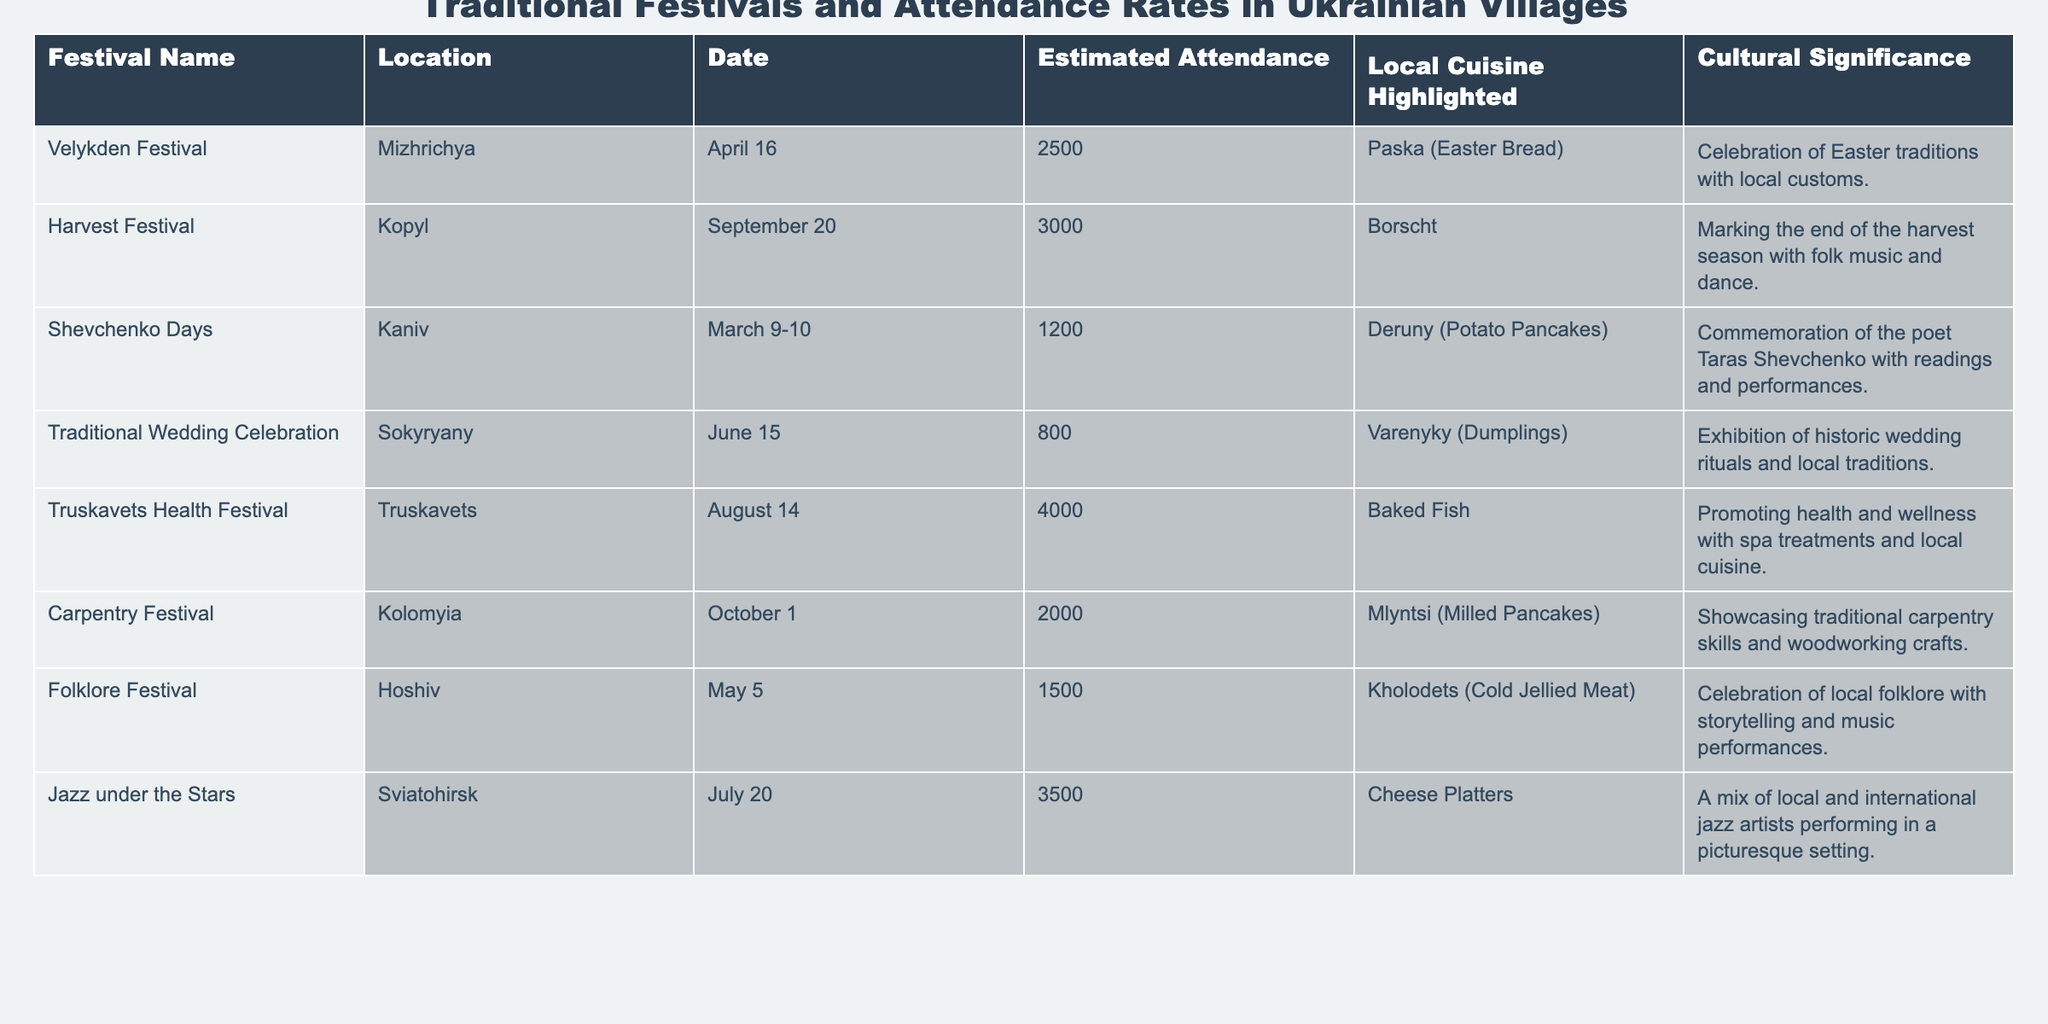What is the estimated attendance at the Harvest Festival? The table lists the Harvest Festival located in Kopyl on September 20, with an estimated attendance of 3000.
Answer: 3000 Which festival has the highest estimated attendance? After reviewing the attendance figures, the Truskavets Health Festival has the highest attendance of 4000.
Answer: 4000 What local cuisine is highlighted at the Shevchenko Days festival? The Shevchenko Days festival features Deruny (Potato Pancakes) as the highlighted local cuisine.
Answer: Deruny (Potato Pancakes) Is Velykden Festival celebrated in April? The Velykden Festival is scheduled for April 16, confirming that it is indeed celebrated in April.
Answer: Yes How many festivals are celebrated in the month of June? By checking the table, only the Traditional Wedding Celebration occurs in June, specifically on June 15, indicating there is one festival in June.
Answer: 1 What is the average estimated attendance of all festivals listed? Calculating the total attendance (2500 + 3000 + 1200 + 800 + 4000 + 2000 + 1500 + 3500) gives 21500, and dividing this by 8 (the number of festivals) results in an average of 2687.5.
Answer: 2687.5 Which festival occurs closest to the summer solstice? The Traditional Wedding Celebration on June 15 is the closest to the summer solstice (around June 21) compared to other festivals.
Answer: Traditional Wedding Celebration Do more festivals focus on local cuisine or cultural significance? Each festival has both components, but all festivals highlight local cuisine; since there are 8 festivals, this indicates cuisine focus is present in all.
Answer: Local cuisine focus in all What is the attendance difference between Jazz under the Stars and Traditional Wedding Celebration? The attendance for Jazz under the Stars is 3500, and for Tradition Wedding Celebration, it is 800. The difference is 3500 - 800 = 2700.
Answer: 2700 